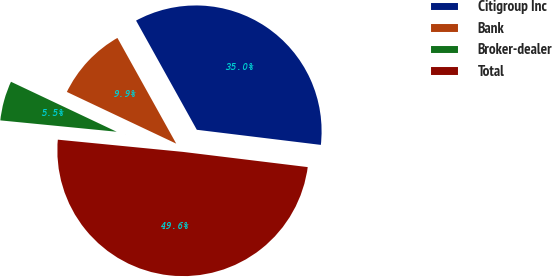<chart> <loc_0><loc_0><loc_500><loc_500><pie_chart><fcel>Citigroup Inc<fcel>Bank<fcel>Broker-dealer<fcel>Total<nl><fcel>35.01%<fcel>9.89%<fcel>5.48%<fcel>49.62%<nl></chart> 